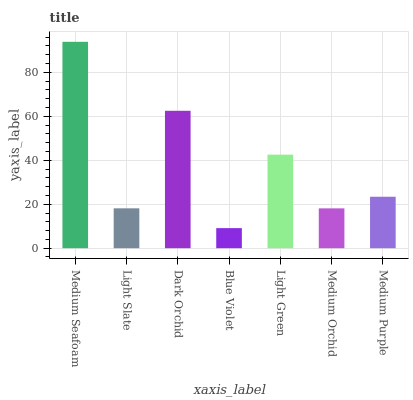Is Blue Violet the minimum?
Answer yes or no. Yes. Is Medium Seafoam the maximum?
Answer yes or no. Yes. Is Light Slate the minimum?
Answer yes or no. No. Is Light Slate the maximum?
Answer yes or no. No. Is Medium Seafoam greater than Light Slate?
Answer yes or no. Yes. Is Light Slate less than Medium Seafoam?
Answer yes or no. Yes. Is Light Slate greater than Medium Seafoam?
Answer yes or no. No. Is Medium Seafoam less than Light Slate?
Answer yes or no. No. Is Medium Purple the high median?
Answer yes or no. Yes. Is Medium Purple the low median?
Answer yes or no. Yes. Is Medium Seafoam the high median?
Answer yes or no. No. Is Medium Orchid the low median?
Answer yes or no. No. 